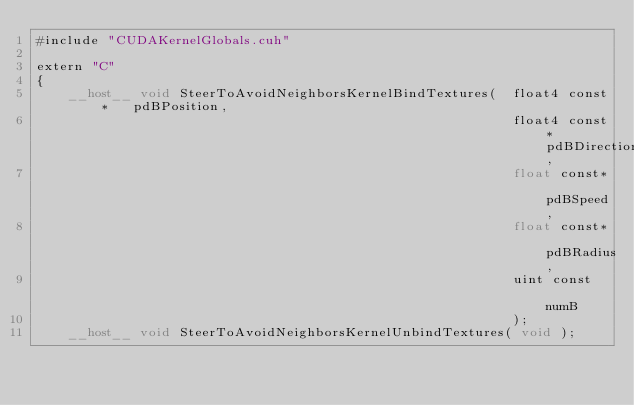<code> <loc_0><loc_0><loc_500><loc_500><_Cuda_>#include "CUDAKernelGlobals.cuh"

extern "C"
{
	__host__ void SteerToAvoidNeighborsKernelBindTextures(	float4 const*	pdBPosition,
															float4 const*	pdBDirection,
															float const*	pdBSpeed,
															float const*	pdBRadius,
															uint const		numB
															);
	__host__ void SteerToAvoidNeighborsKernelUnbindTextures( void );
</code> 